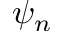<formula> <loc_0><loc_0><loc_500><loc_500>\psi _ { n }</formula> 